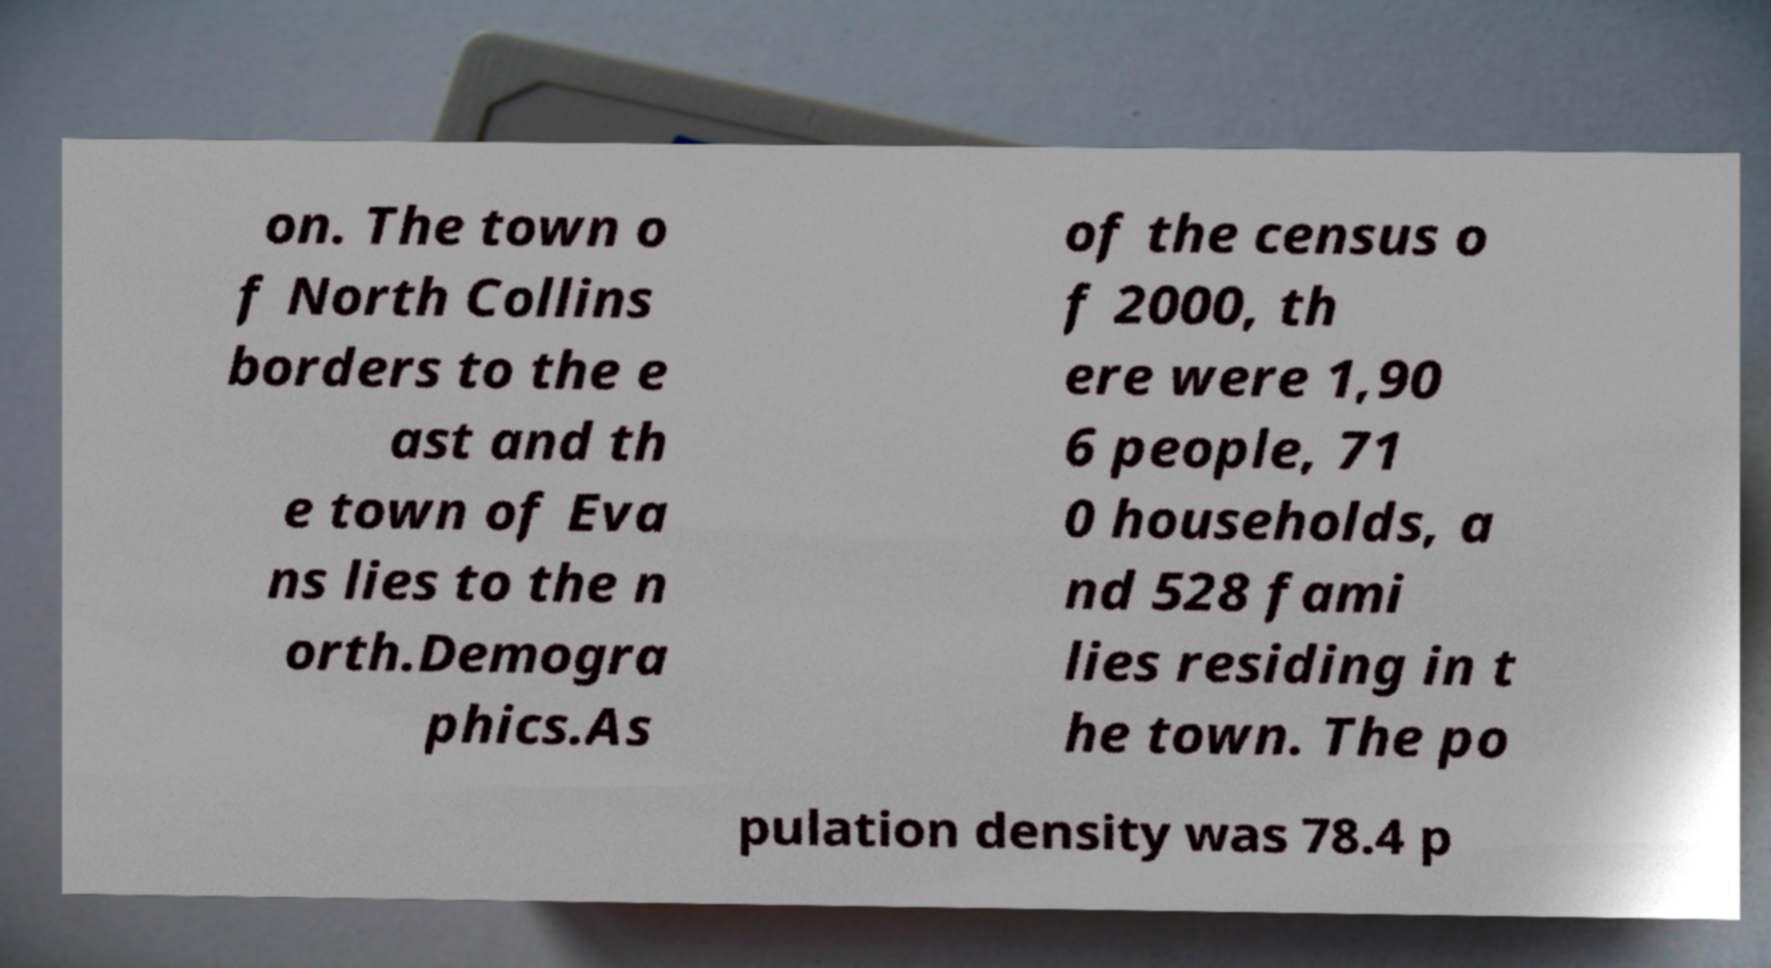Please read and relay the text visible in this image. What does it say? on. The town o f North Collins borders to the e ast and th e town of Eva ns lies to the n orth.Demogra phics.As of the census o f 2000, th ere were 1,90 6 people, 71 0 households, a nd 528 fami lies residing in t he town. The po pulation density was 78.4 p 